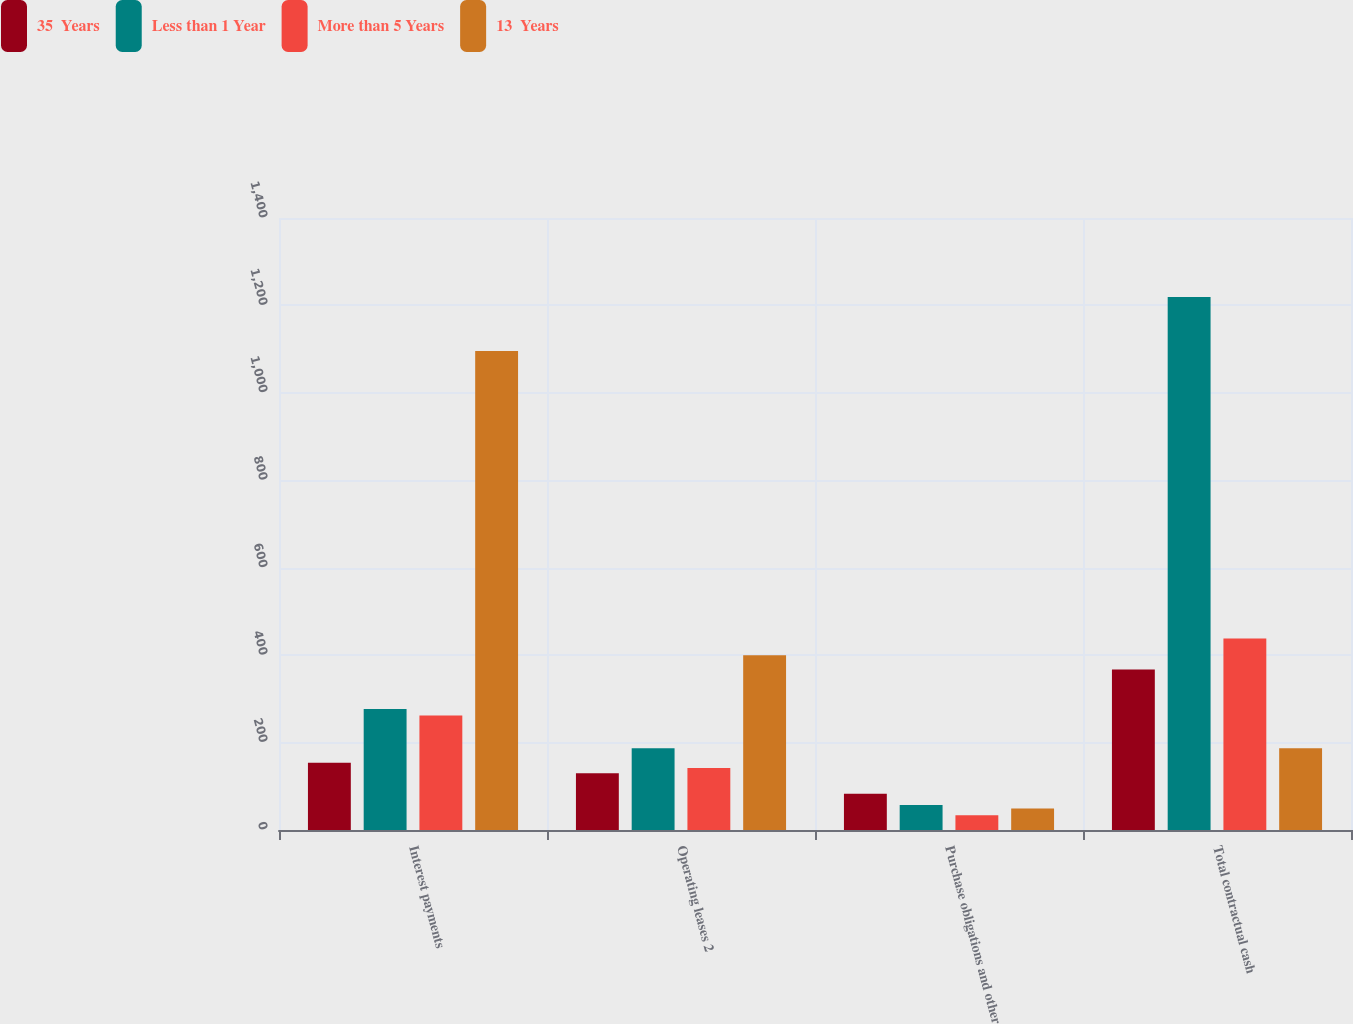Convert chart to OTSL. <chart><loc_0><loc_0><loc_500><loc_500><stacked_bar_chart><ecel><fcel>Interest payments<fcel>Operating leases 2<fcel>Purchase obligations and other<fcel>Total contractual cash<nl><fcel>35  Years<fcel>154<fcel>130<fcel>83<fcel>367<nl><fcel>Less than 1 Year<fcel>277<fcel>187<fcel>57<fcel>1219<nl><fcel>More than 5 Years<fcel>262<fcel>142<fcel>34<fcel>438<nl><fcel>13  Years<fcel>1096<fcel>400<fcel>49<fcel>187<nl></chart> 